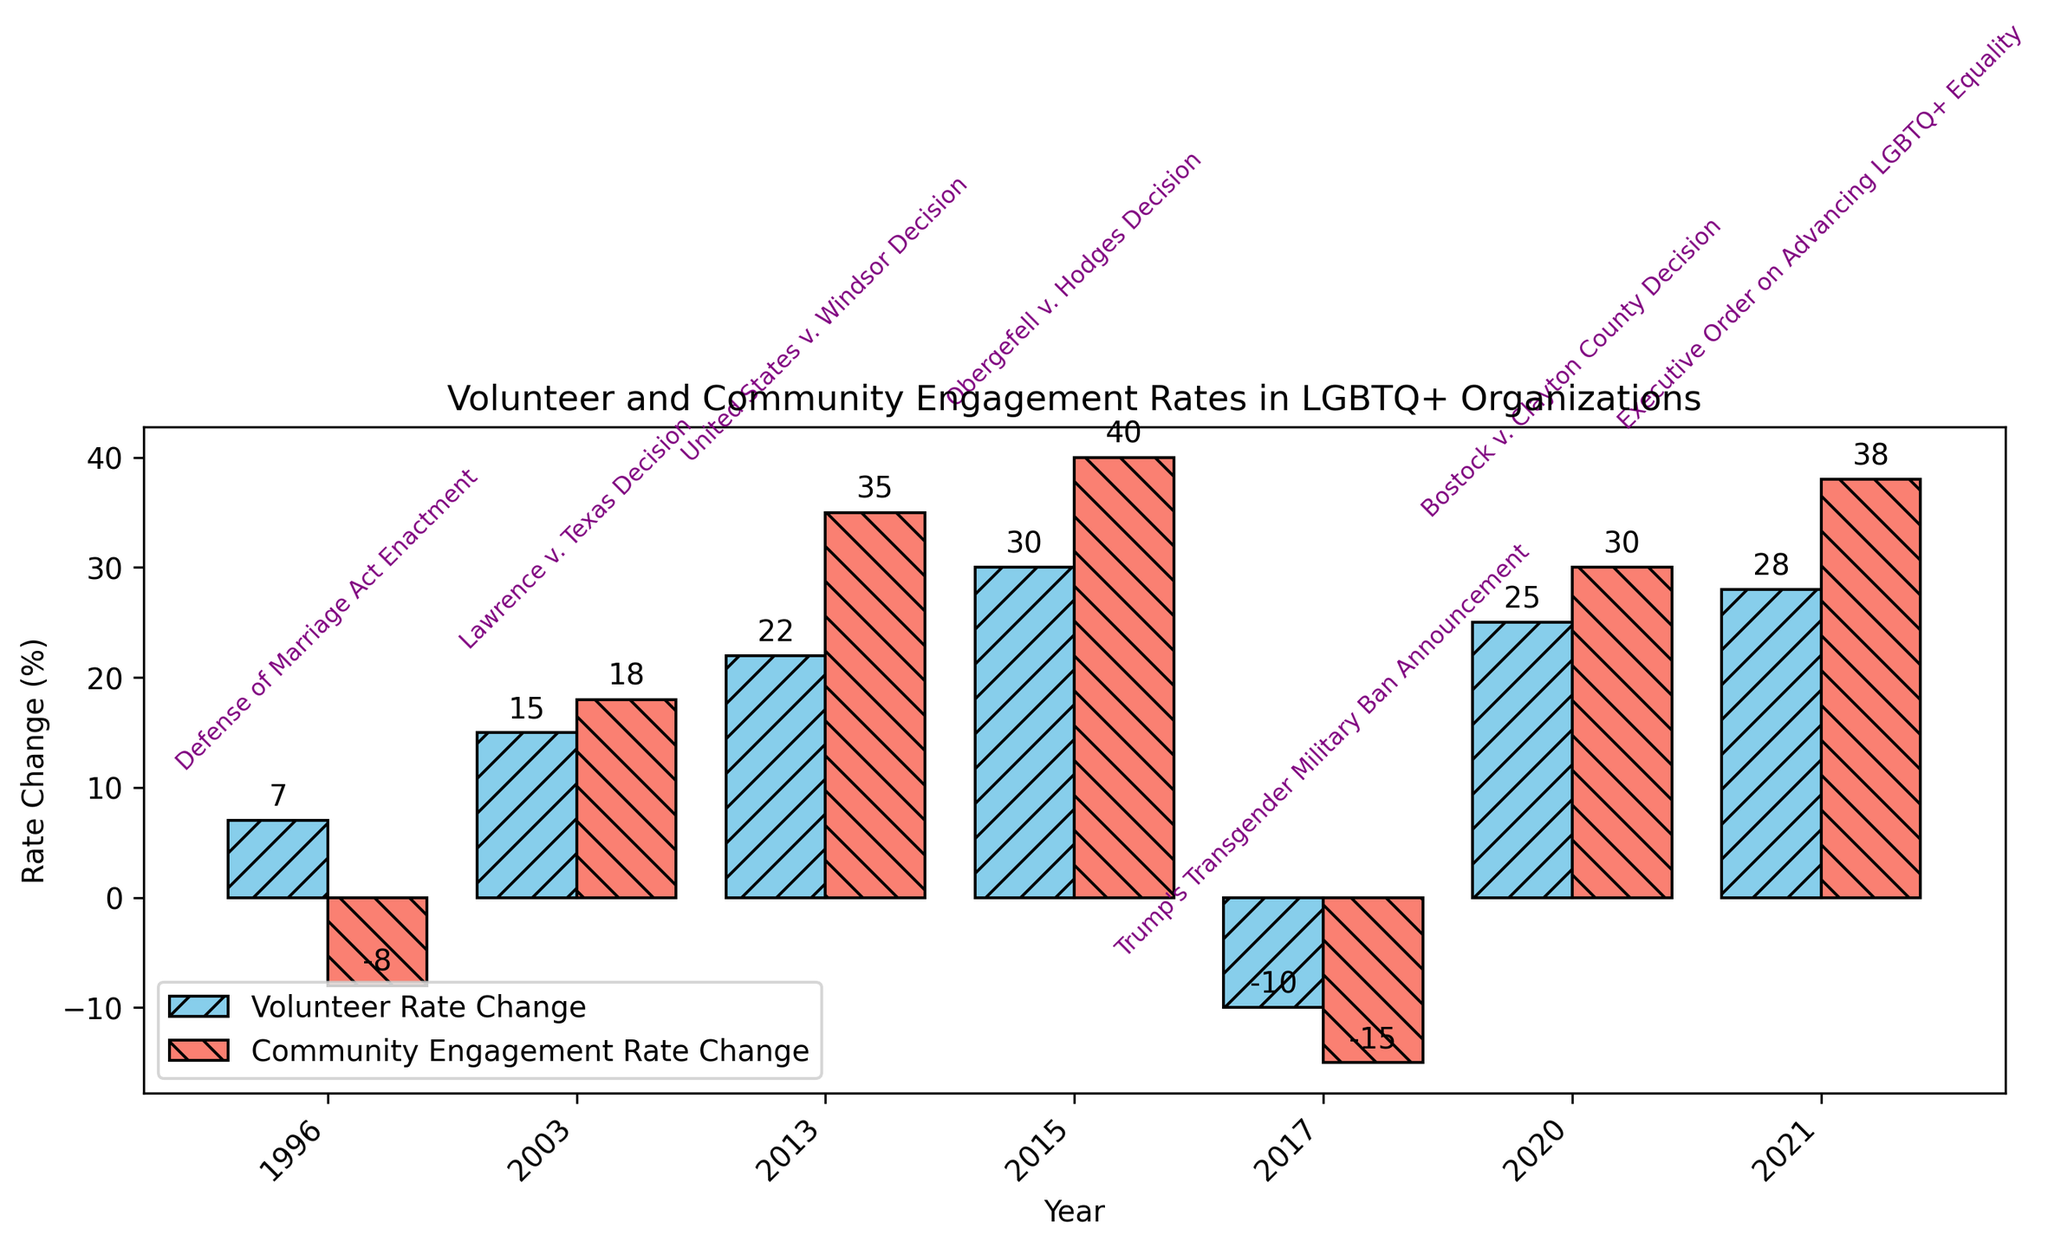what event had the highest increase in community engagement rate? The event with the highest increase will be the one whose bar representing the community engagement rate change is the tallest. The tallest bar for community engagement rate change is the one at 2015 for the Obergefell v. Hodges Decision, with an increase of 40%.
Answer: Obergefell v. Hodges Decision which event had both positive volunteer and community engagement rate changes? We need to identify the events where both the volunteer rate change and the community engagement rate change bars are above the zero line (positive). These events are the Lawrence v. Texas Decision (2003), the United States v. Windsor Decision (2013), the Obergefell v. Hodges Decision (2015), the Bostock v. Clayton County Decision (2020), and the Executive Order on Advancing LGBTQ+ Equality (2021).
Answer: Lawrence v. Texas Decision, United States v. Windsor Decision, Obergefell v. Hodges Decision, Bostock v. Clayton County Decision, Executive Order on Advancing LGBTQ+ Equality which event had the greatest decrease in the volunteer rate? The greatest decrease in the volunteer rate will be represented by the lowest negative bar in the volunteer rate change section. The lowest negative bar is at 2017 for Trump's Transgender Military Ban Announcement, with a decrease of 10 percentage points.
Answer: Trump's Transgender Military Ban Announcement between the Lawrence v. Texas Decision (2003) and the United States v. Windsor Decision (2013), which had a higher community engagement rate change? Look at the community engagement rate change bars for 2003 and 2013. The bar for 2013 is taller than the one for 2003, indicating a higher rate change. The United States v. Windsor Decision had a rate change of 35%, while the Lawrence v. Texas Decision had 18%.
Answer: United States v. Windsor Decision what is the summed increase in community engagement rate change for all events after 2015? Add the community engagement rate changes for the events after 2015: 2020 (Bostock v. Clayton County Decision) and 2021 (Executive Order on Advancing LGBTQ+ Equality). The values are 30 and 38 respectively. So, 30 + 38 = 68%.
Answer: 68% how many events showed a negative change in volunteer rate? Look at the bars representing the volunteer rate change and count those that fall below the zero line. There are two events with negative volunteer rate changes: 1996 (Defense of Marriage Act Enactment) and 2017 (Trump's Transgender Military Ban Announcement).
Answer: 2 comparing 1996 and 2003, which event had a greater absolute change in community engagement rate? Find the absolute values of the community engagement rate changes for 1996 and 2003 and compare them. In 1996, the change was -8%, and in 2003, it was 18%. The absolute values are 8 and 18. Therefore, 2003 had a greater absolute change.
Answer: Lawrence v. Texas Decision what is the average change in volunteer rate for all events? Sum the volunteer rate changes for all events and divide by the number of events. The values are 7, 15, 22, 30, -10, 25, and 28. Sum: 7 + 15 + 22 + 30 - 10 + 25 + 28 = 117. Number of events is 7. Average: 117 / 7 ≈ 16.71%.
Answer: 16.71% which year's event resulted in the smallest combined rate change for both volunteer and community engagement? For each year, sum the volunteer and community engagement rate changes to find the combined rate change. Then, find the smallest sum. 
1996: 7 - 8 = -1
2003: 15 + 18 = 33
2013: 22 + 35 = 57
2015: 30 + 40 = 70
2017: -10 - 15 = -25
2020: 25 + 30 = 55
2021: 28 + 38 = 66
The smallest combined rate change is -25 in 2017.
Answer: Trump's Transgender Military Ban Announcement 